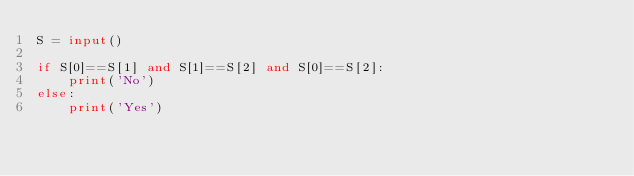Convert code to text. <code><loc_0><loc_0><loc_500><loc_500><_Python_>S = input()

if S[0]==S[1] and S[1]==S[2] and S[0]==S[2]:
    print('No')
else:
    print('Yes')</code> 